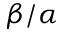Convert formula to latex. <formula><loc_0><loc_0><loc_500><loc_500>\beta / \alpha</formula> 